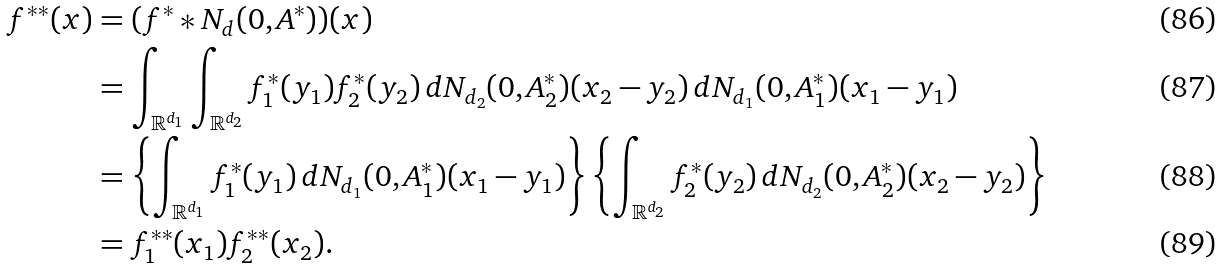Convert formula to latex. <formula><loc_0><loc_0><loc_500><loc_500>f ^ { * * } ( x ) & = ( f ^ { * } \ast N _ { d } ( 0 , A ^ { * } ) ) ( x ) \\ & = \int _ { \mathbb { R } ^ { d _ { 1 } } } \int _ { \mathbb { R } ^ { d _ { 2 } } } f _ { 1 } ^ { * } ( y _ { 1 } ) f _ { 2 } ^ { * } ( y _ { 2 } ) \, d N _ { d _ { 2 } } ( 0 , A _ { 2 } ^ { * } ) ( x _ { 2 } - y _ { 2 } ) \, d N _ { d _ { 1 } } ( 0 , A _ { 1 } ^ { * } ) ( x _ { 1 } - y _ { 1 } ) \\ & = \left \{ \int _ { \mathbb { R } ^ { d _ { 1 } } } f _ { 1 } ^ { * } ( y _ { 1 } ) \, d N _ { d _ { 1 } } ( 0 , A _ { 1 } ^ { * } ) ( x _ { 1 } - y _ { 1 } ) \right \} \left \{ \int _ { \mathbb { R } ^ { d _ { 2 } } } f _ { 2 } ^ { * } ( y _ { 2 } ) \, d N _ { d _ { 2 } } ( 0 , A _ { 2 } ^ { * } ) ( x _ { 2 } - y _ { 2 } ) \right \} \\ & = f ^ { * * } _ { 1 } ( x _ { 1 } ) f ^ { * * } _ { 2 } ( x _ { 2 } ) .</formula> 